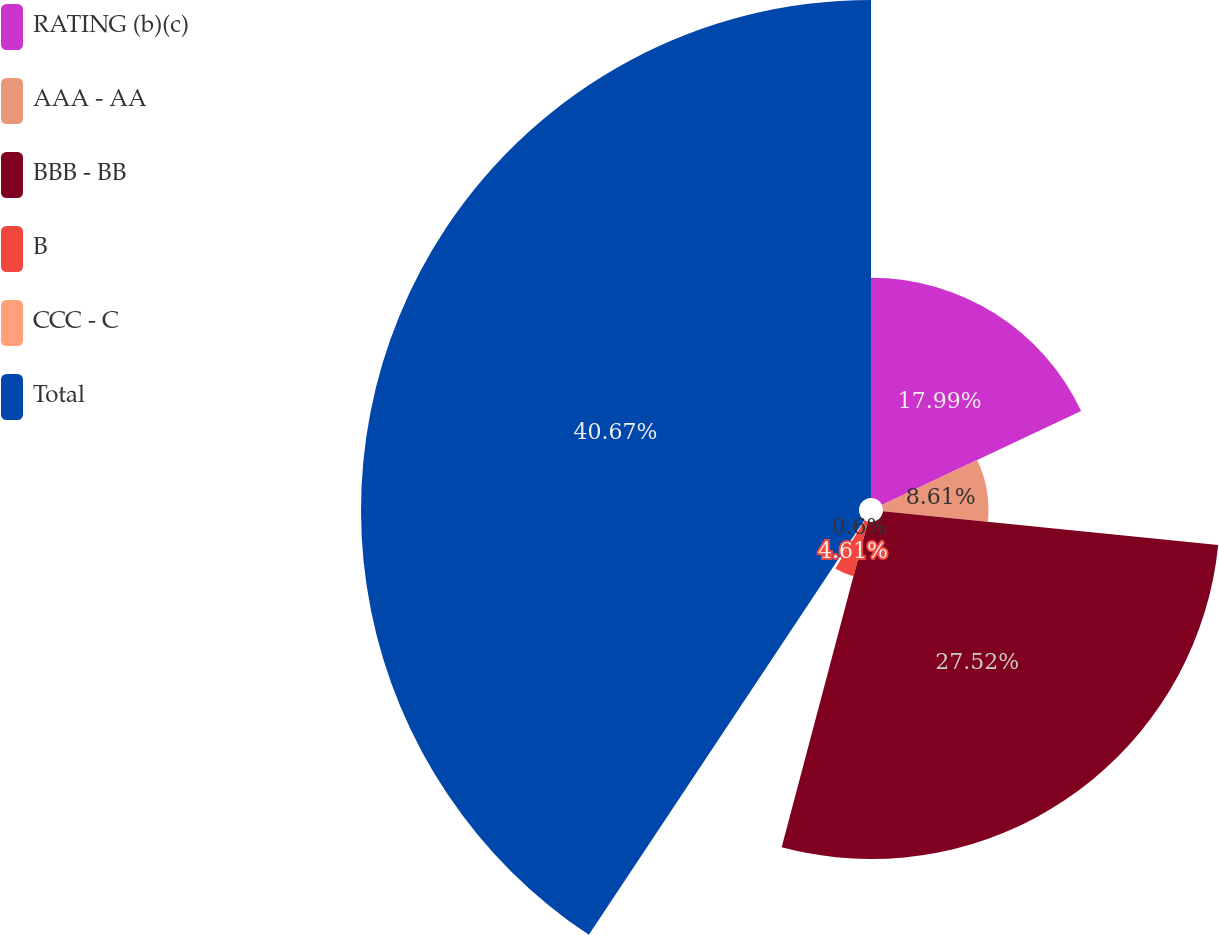Convert chart. <chart><loc_0><loc_0><loc_500><loc_500><pie_chart><fcel>RATING (b)(c)<fcel>AAA - AA<fcel>BBB - BB<fcel>B<fcel>CCC - C<fcel>Total<nl><fcel>17.99%<fcel>8.61%<fcel>27.52%<fcel>4.61%<fcel>0.6%<fcel>40.67%<nl></chart> 